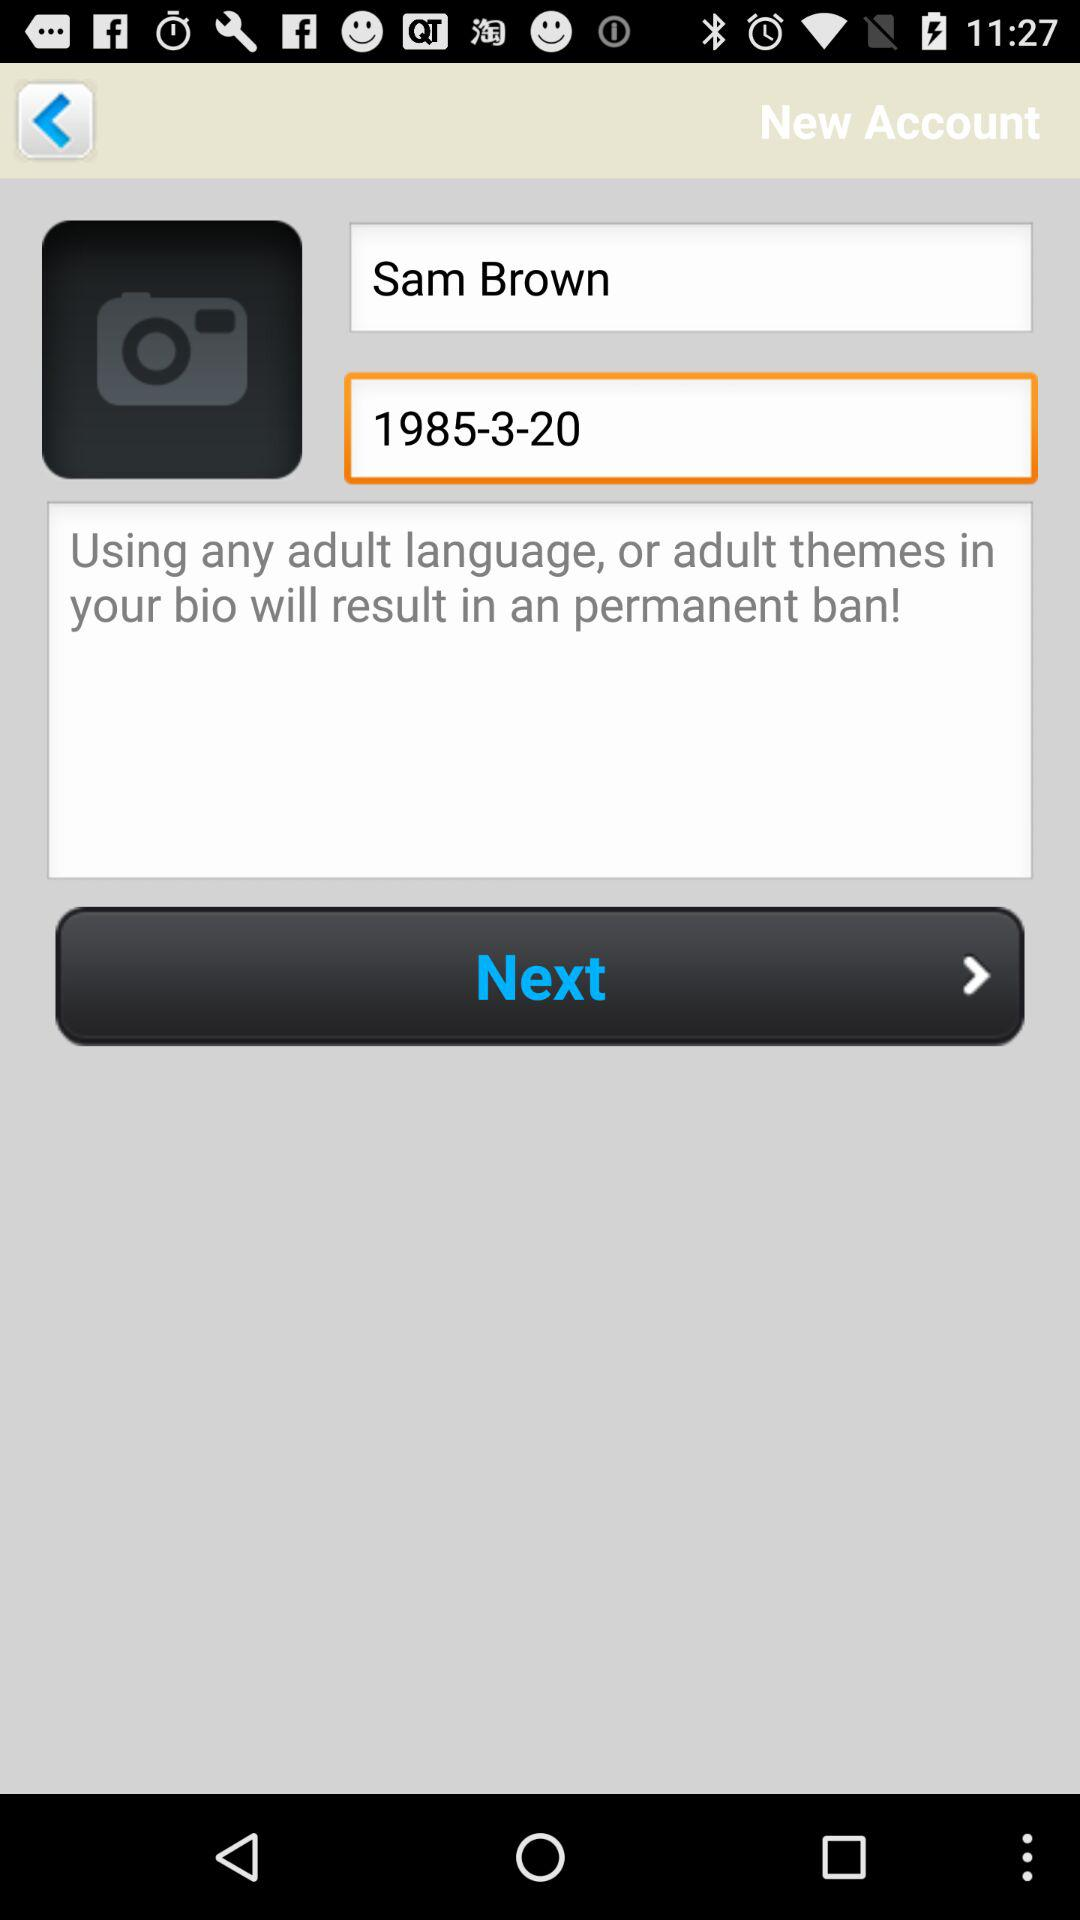What is the name of the user? The user name is Sam Brown. 